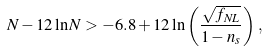<formula> <loc_0><loc_0><loc_500><loc_500>N - 1 2 \ln N > - 6 . 8 + 1 2 \ln \left ( \frac { \sqrt { f _ { N L } } } { 1 - n _ { s } } \right ) \, ,</formula> 